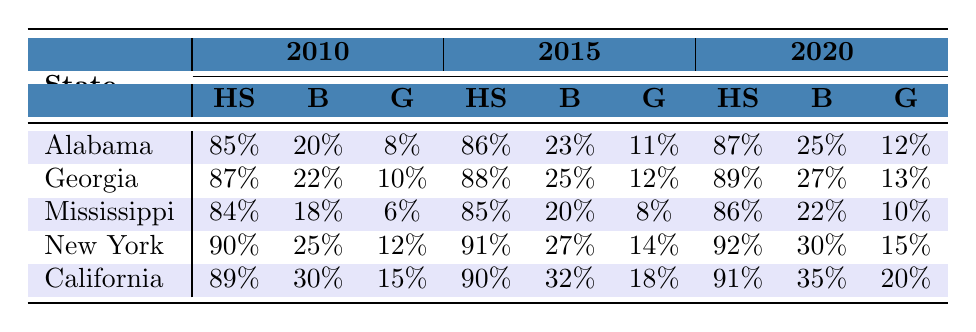What was the percentage of African American women in California who graduated from high school in 2010? In the table under the 2010 column for California, the value for high school graduation is shown as 89%.
Answer: 89% Which state had the highest percentage of African American women with bachelor's degrees in 2020? Looking at the 2020 column, California has a bachelor's degree percentage of 35%, which is the highest among the states listed.
Answer: California What is the difference in the percentage of African American women with graduate degrees in New York between 2010 and 2020? The percentage with graduate degrees in New York is 12% in 2010 and 15% in 2020. The difference is calculated as 15% - 12% = 3%.
Answer: 3% Did the percentage of African American women with bachelor's degrees in Georgia increase from 2010 to 2015? In 2010, Georgia had 22% for bachelor's degrees, and in 2015 it increased to 25%. This indicates an increase.
Answer: Yes What was the average percentage of high school graduation among African American women in the states listed for 2015? The percentages for high school graduation in 2015 are 86% (Alabama), 88% (Georgia), 85% (Mississippi), 91% (New York), and 90% (California). To find the average, sum them (86 + 88 + 85 + 91 + 90 = 440) and divide by 5, resulting in 440/5 = 88%.
Answer: 88% What is the trend in graduate degree attainment for African American women in California from 2010 to 2020? The data shows that the percentage of graduate degree attainments in California increased from 15% in 2010 to 20% in 2020, indicating a positive trend.
Answer: Increasing Which state had the lowest percentage of African American women with bachelor’s degrees in 2015? Upon reviewing the 2015 column, Mississippi has the lowest percentage of 20% for bachelor's degrees compared to other states listed.
Answer: Mississippi How much did the percentage of graduate degrees among African American women in Alabama grow from 2010 to 2020? The table shows that Alabama had 8% for graduate degrees in 2010 and increased to 12% in 2020. The growth is 12% - 8% = 4%.
Answer: 4% Was the percentage of African American women in New York who earned bachelor’s degrees higher than the percentage in Mississippi in 2020? In 2020, New York had 30% for bachelor's degrees while Mississippi had 22%. Since 30% is greater than 22%, the statement is true.
Answer: Yes What is the rank of Georgia in terms of high school graduation percentages among the states for the year 2020? In 2020, Georgia had 89%, which places it third among the states listed, after New York (92%) and California (91%).
Answer: Third 